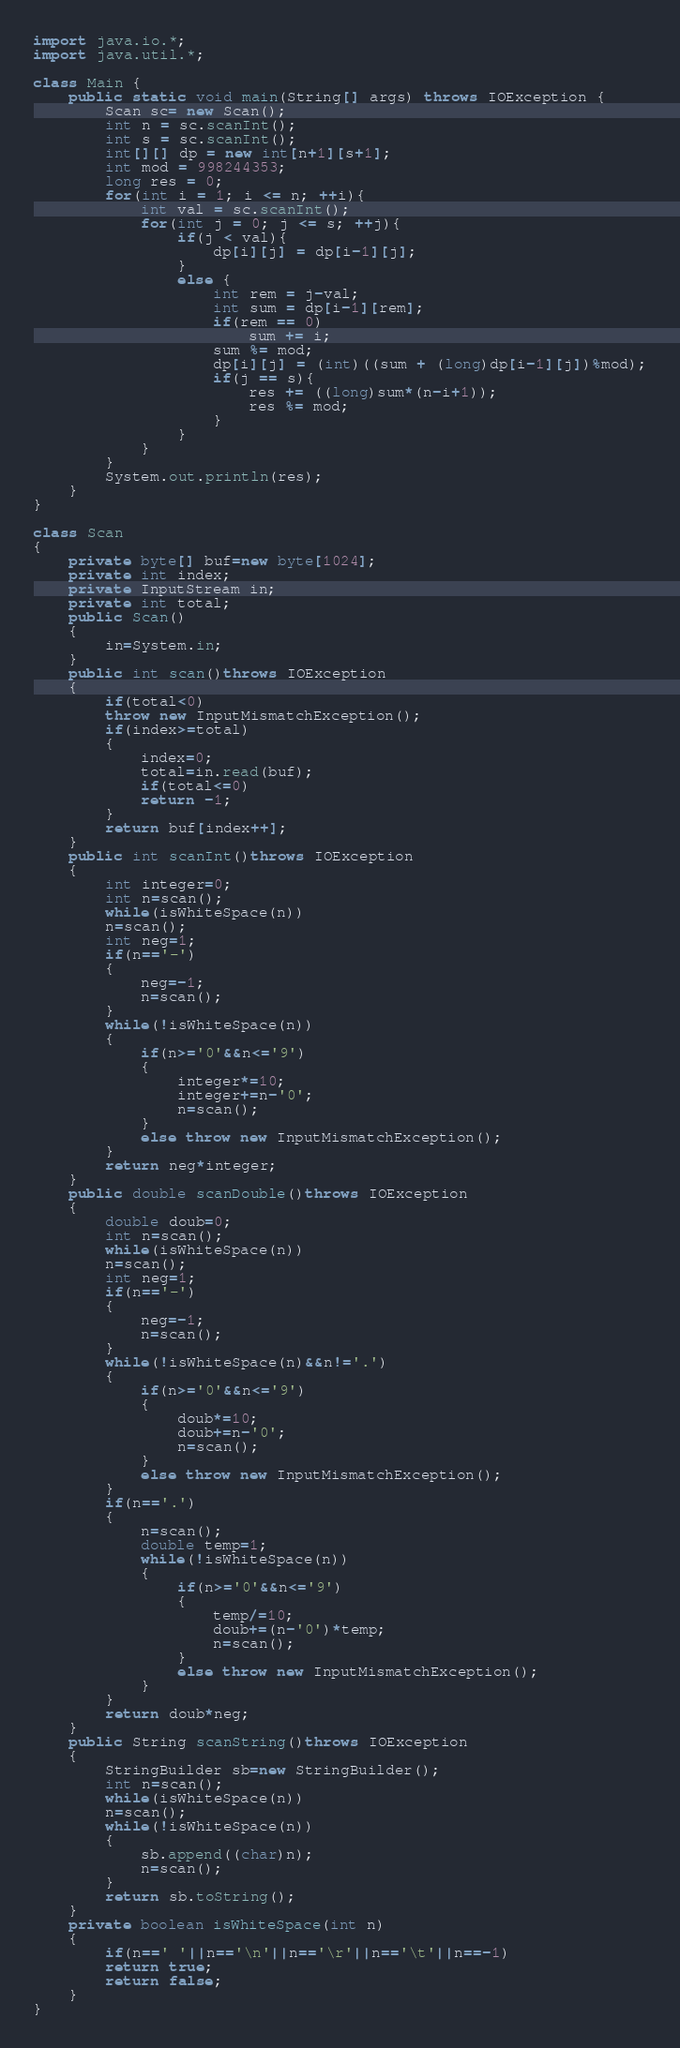<code> <loc_0><loc_0><loc_500><loc_500><_Java_>import java.io.*;
import java.util.*;

class Main {
    public static void main(String[] args) throws IOException {
        Scan sc= new Scan();
        int n = sc.scanInt();
        int s = sc.scanInt();
        int[][] dp = new int[n+1][s+1];
        int mod = 998244353;
        long res = 0;
        for(int i = 1; i <= n; ++i){
            int val = sc.scanInt();
            for(int j = 0; j <= s; ++j){
                if(j < val){
                    dp[i][j] = dp[i-1][j];
                }
                else {
                    int rem = j-val;
                    int sum = dp[i-1][rem];
                    if(rem == 0)
                        sum += i;
                    sum %= mod;
                    dp[i][j] = (int)((sum + (long)dp[i-1][j])%mod);
                    if(j == s){
                        res += ((long)sum*(n-i+1));
                        res %= mod;
                    }
                }
            }
        }
        System.out.println(res);
    }
}

class Scan
{
    private byte[] buf=new byte[1024];
    private int index;
    private InputStream in;
    private int total;
    public Scan()
    {
        in=System.in;
    }
    public int scan()throws IOException
    {
        if(total<0)
        throw new InputMismatchException();
        if(index>=total)
        {
            index=0;
            total=in.read(buf);
            if(total<=0)
            return -1;
        }
        return buf[index++];
    }
    public int scanInt()throws IOException
    {
        int integer=0;
        int n=scan();
        while(isWhiteSpace(n))
        n=scan();
        int neg=1;
        if(n=='-')
        {
            neg=-1;
            n=scan();
        }
        while(!isWhiteSpace(n))
        {
            if(n>='0'&&n<='9')
            {
                integer*=10;
                integer+=n-'0';
                n=scan();
            }
            else throw new InputMismatchException();
        }
        return neg*integer;
    }
    public double scanDouble()throws IOException
    {
        double doub=0;
        int n=scan();
        while(isWhiteSpace(n))
        n=scan();
        int neg=1;
        if(n=='-')
        {
            neg=-1;
            n=scan();
        }
        while(!isWhiteSpace(n)&&n!='.')
        {
            if(n>='0'&&n<='9')
            {
                doub*=10;
                doub+=n-'0';
                n=scan();
            }
            else throw new InputMismatchException();
        }
        if(n=='.')
        {
            n=scan();
            double temp=1;
            while(!isWhiteSpace(n))
            {
                if(n>='0'&&n<='9')
                {
                    temp/=10;
                    doub+=(n-'0')*temp;
                    n=scan();
                }
                else throw new InputMismatchException();
            }
        }
        return doub*neg;
    }
    public String scanString()throws IOException
    {
        StringBuilder sb=new StringBuilder();
        int n=scan();
        while(isWhiteSpace(n))
        n=scan();
        while(!isWhiteSpace(n))
        {
            sb.append((char)n);
            n=scan();
        }
        return sb.toString();
    }
    private boolean isWhiteSpace(int n)
    {
        if(n==' '||n=='\n'||n=='\r'||n=='\t'||n==-1)
        return true;
        return false;
    }
}</code> 